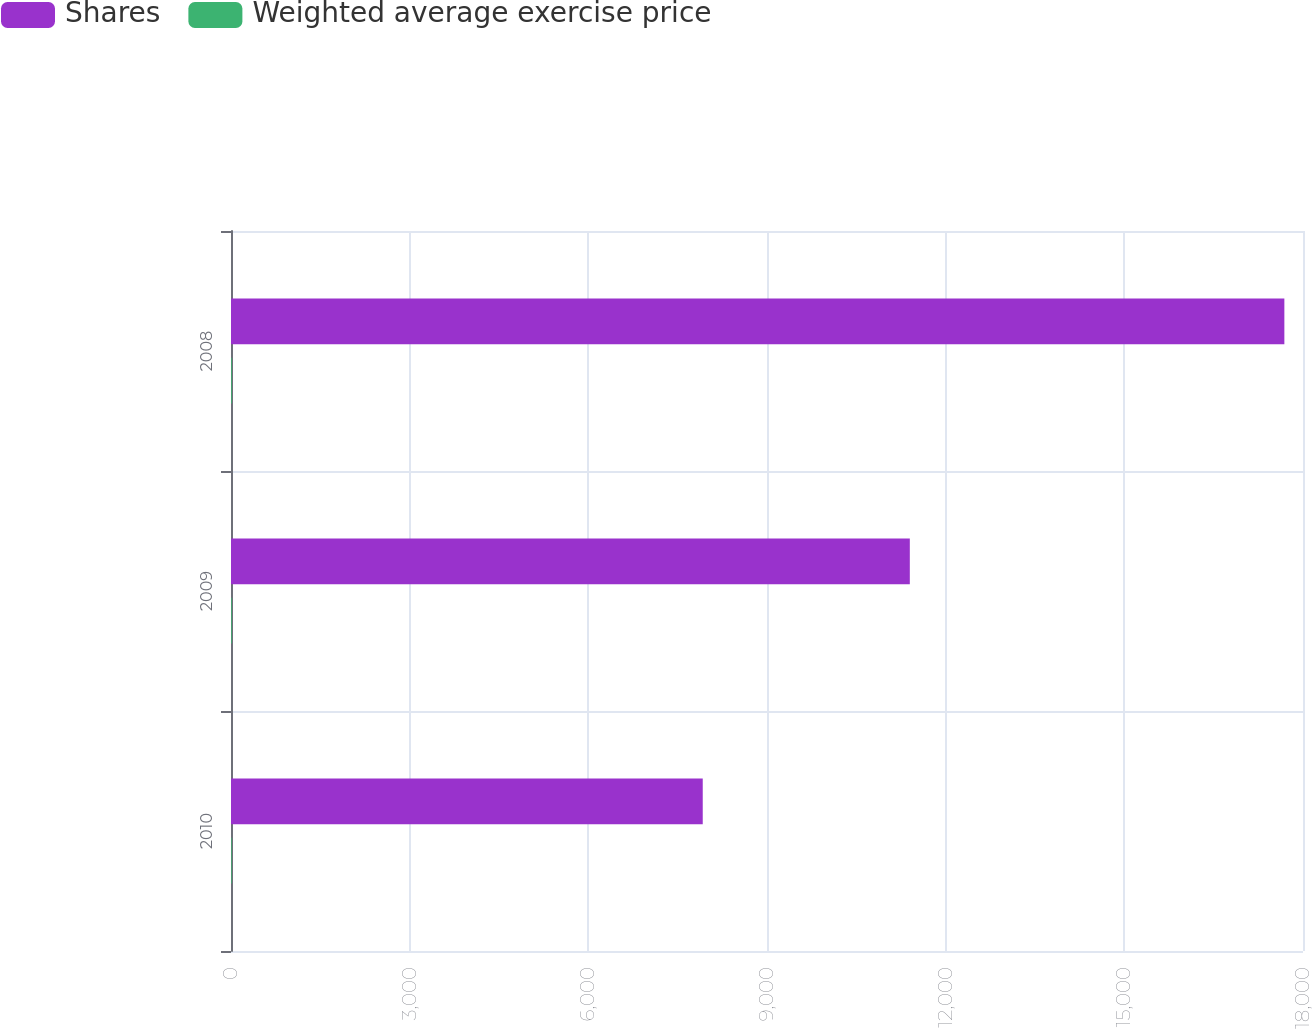Convert chart. <chart><loc_0><loc_0><loc_500><loc_500><stacked_bar_chart><ecel><fcel>2010<fcel>2009<fcel>2008<nl><fcel>Shares<fcel>7921<fcel>11398<fcel>17687<nl><fcel>Weighted average exercise price<fcel>11.09<fcel>12.2<fcel>12.86<nl></chart> 